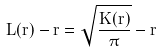Convert formula to latex. <formula><loc_0><loc_0><loc_500><loc_500>L ( r ) - r = \sqrt { \frac { K ( r ) } { \pi } } - r</formula> 